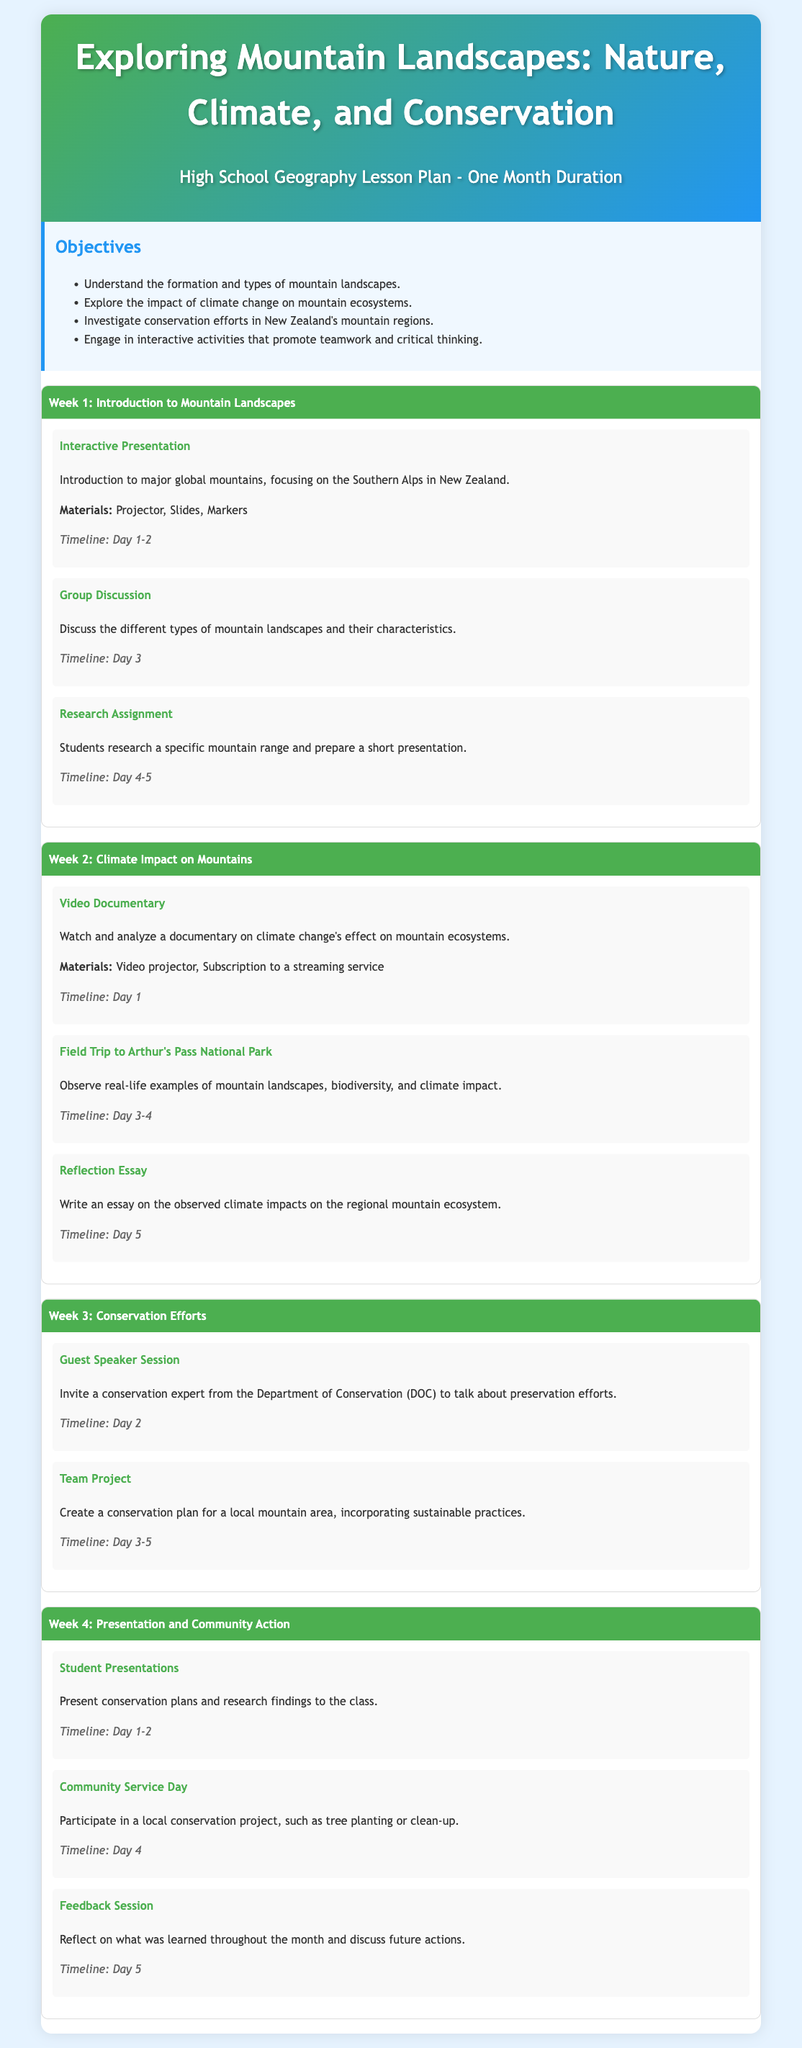What is the title of the lesson plan? The title of the lesson plan is displayed prominently at the top of the document.
Answer: Exploring Mountain Landscapes: Nature, Climate, and Conservation How many weeks is the lesson plan designed for? The document contains sections labeled by weeks, indicating the duration of the lesson plan.
Answer: One Month What is an activity included in Week 1? Each week contains a list of activities, clearly outlined with their corresponding details.
Answer: Interactive Presentation Which national park is mentioned for the field trip in Week 2? The field trip for Week 2 specifically highlights a national park within New Zealand.
Answer: Arthur's Pass National Park What is the main objective regarding mountain ecosystems? The objectives section provides clear goals for students to achieve through the lesson plan.
Answer: Explore the impact of climate change on mountain ecosystems What type of session is scheduled with a conservation expert? The specific engagement with an expert is mentioned explicitly in Week 3 of the document.
Answer: Guest Speaker Session What activity involves community participation toward the end of the plan? The activities for the final week conclude with a collaborative effort mentioned in the last week.
Answer: Community Service Day 